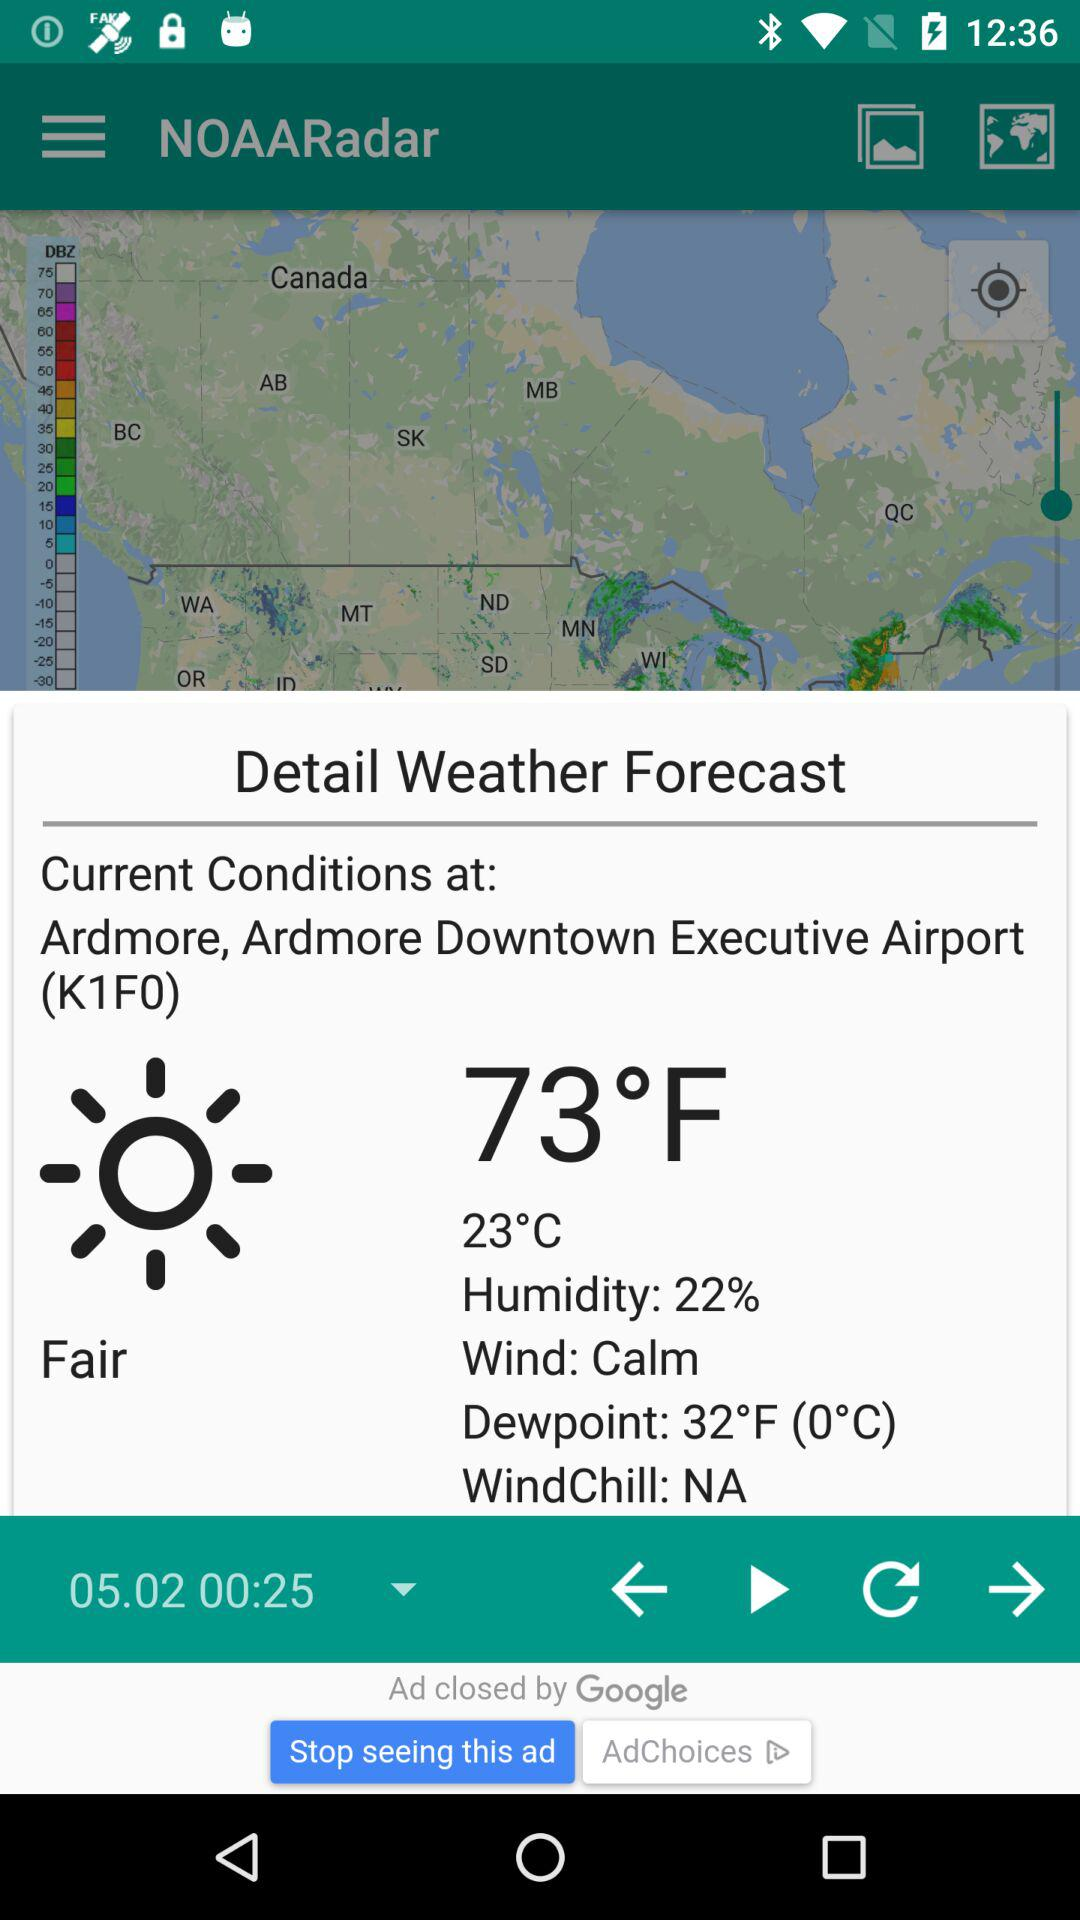How many degrees Fahrenheit is the temperature difference between the dewpoint and the current temperature?
Answer the question using a single word or phrase. 41 